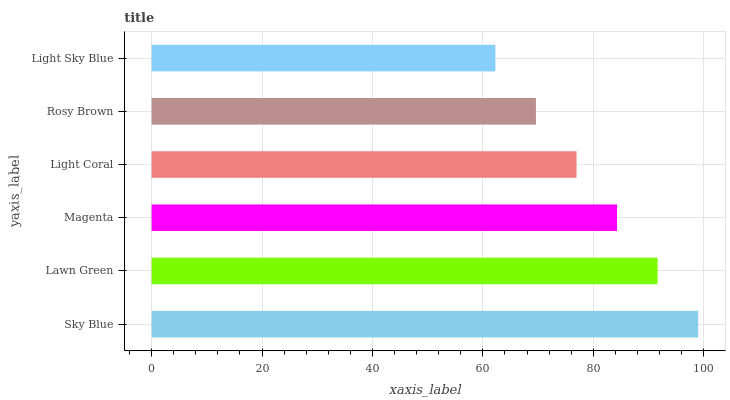Is Light Sky Blue the minimum?
Answer yes or no. Yes. Is Sky Blue the maximum?
Answer yes or no. Yes. Is Lawn Green the minimum?
Answer yes or no. No. Is Lawn Green the maximum?
Answer yes or no. No. Is Sky Blue greater than Lawn Green?
Answer yes or no. Yes. Is Lawn Green less than Sky Blue?
Answer yes or no. Yes. Is Lawn Green greater than Sky Blue?
Answer yes or no. No. Is Sky Blue less than Lawn Green?
Answer yes or no. No. Is Magenta the high median?
Answer yes or no. Yes. Is Light Coral the low median?
Answer yes or no. Yes. Is Light Sky Blue the high median?
Answer yes or no. No. Is Lawn Green the low median?
Answer yes or no. No. 